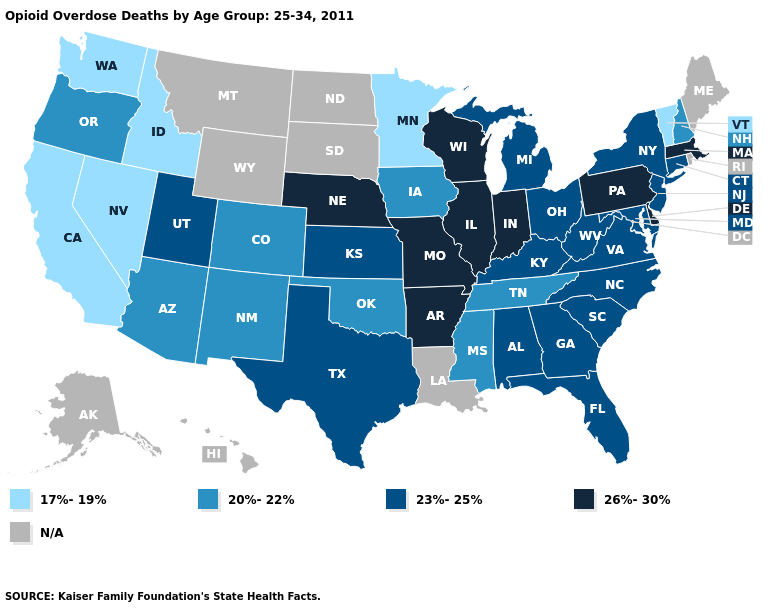What is the lowest value in the USA?
Quick response, please. 17%-19%. Among the states that border North Carolina , which have the highest value?
Answer briefly. Georgia, South Carolina, Virginia. What is the lowest value in the USA?
Short answer required. 17%-19%. Does the map have missing data?
Quick response, please. Yes. Among the states that border Utah , does Nevada have the highest value?
Keep it brief. No. What is the value of Wyoming?
Short answer required. N/A. What is the value of Oregon?
Keep it brief. 20%-22%. What is the lowest value in the South?
Be succinct. 20%-22%. What is the value of West Virginia?
Keep it brief. 23%-25%. What is the highest value in the USA?
Answer briefly. 26%-30%. Name the states that have a value in the range N/A?
Short answer required. Alaska, Hawaii, Louisiana, Maine, Montana, North Dakota, Rhode Island, South Dakota, Wyoming. What is the lowest value in states that border Idaho?
Answer briefly. 17%-19%. Among the states that border Wisconsin , does Illinois have the highest value?
Concise answer only. Yes. What is the value of Maryland?
Short answer required. 23%-25%. 